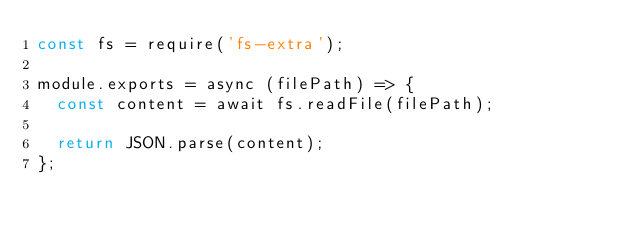Convert code to text. <code><loc_0><loc_0><loc_500><loc_500><_JavaScript_>const fs = require('fs-extra');

module.exports = async (filePath) => {
  const content = await fs.readFile(filePath);

  return JSON.parse(content);
};
</code> 